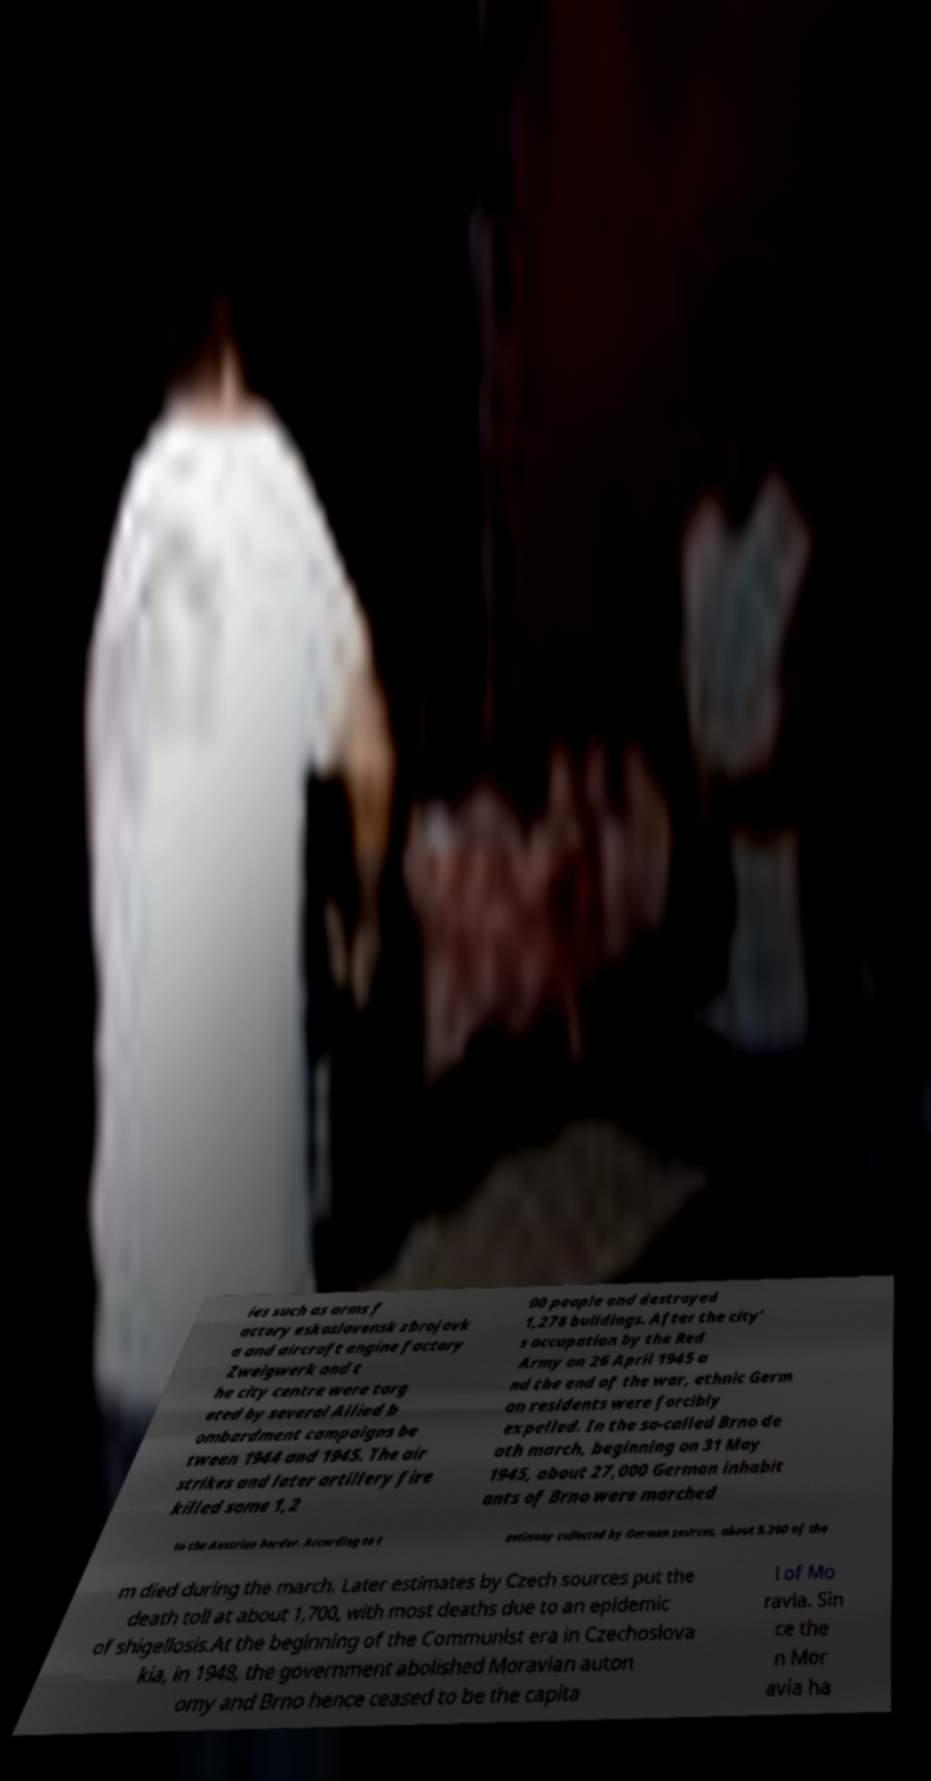Please read and relay the text visible in this image. What does it say? ies such as arms f actory eskoslovensk zbrojovk a and aircraft engine factory Zweigwerk and t he city centre were targ eted by several Allied b ombardment campaigns be tween 1944 and 1945. The air strikes and later artillery fire killed some 1,2 00 people and destroyed 1,278 buildings. After the city' s occupation by the Red Army on 26 April 1945 a nd the end of the war, ethnic Germ an residents were forcibly expelled. In the so-called Brno de ath march, beginning on 31 May 1945, about 27,000 German inhabit ants of Brno were marched to the Austrian border. According to t estimony collected by German sources, about 5,200 of the m died during the march. Later estimates by Czech sources put the death toll at about 1,700, with most deaths due to an epidemic of shigellosis.At the beginning of the Communist era in Czechoslova kia, in 1948, the government abolished Moravian auton omy and Brno hence ceased to be the capita l of Mo ravia. Sin ce the n Mor avia ha 